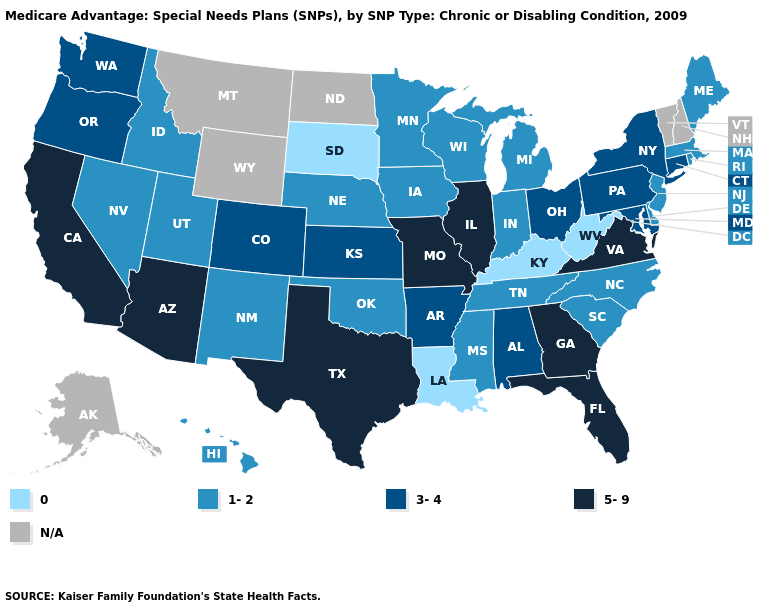What is the value of Massachusetts?
Write a very short answer. 1-2. Name the states that have a value in the range 3-4?
Keep it brief. Alabama, Arkansas, Colorado, Connecticut, Kansas, Maryland, New York, Ohio, Oregon, Pennsylvania, Washington. Does Mississippi have the highest value in the South?
Concise answer only. No. Among the states that border Pennsylvania , does New Jersey have the lowest value?
Give a very brief answer. No. What is the value of Virginia?
Answer briefly. 5-9. Name the states that have a value in the range 5-9?
Answer briefly. Arizona, California, Florida, Georgia, Illinois, Missouri, Texas, Virginia. Does the map have missing data?
Keep it brief. Yes. What is the value of South Carolina?
Keep it brief. 1-2. Is the legend a continuous bar?
Write a very short answer. No. Name the states that have a value in the range 5-9?
Give a very brief answer. Arizona, California, Florida, Georgia, Illinois, Missouri, Texas, Virginia. Does Missouri have the highest value in the USA?
Keep it brief. Yes. Which states have the lowest value in the USA?
Concise answer only. Kentucky, Louisiana, South Dakota, West Virginia. Which states hav the highest value in the South?
Write a very short answer. Florida, Georgia, Texas, Virginia. Among the states that border Washington , does Idaho have the highest value?
Quick response, please. No. What is the value of California?
Give a very brief answer. 5-9. 